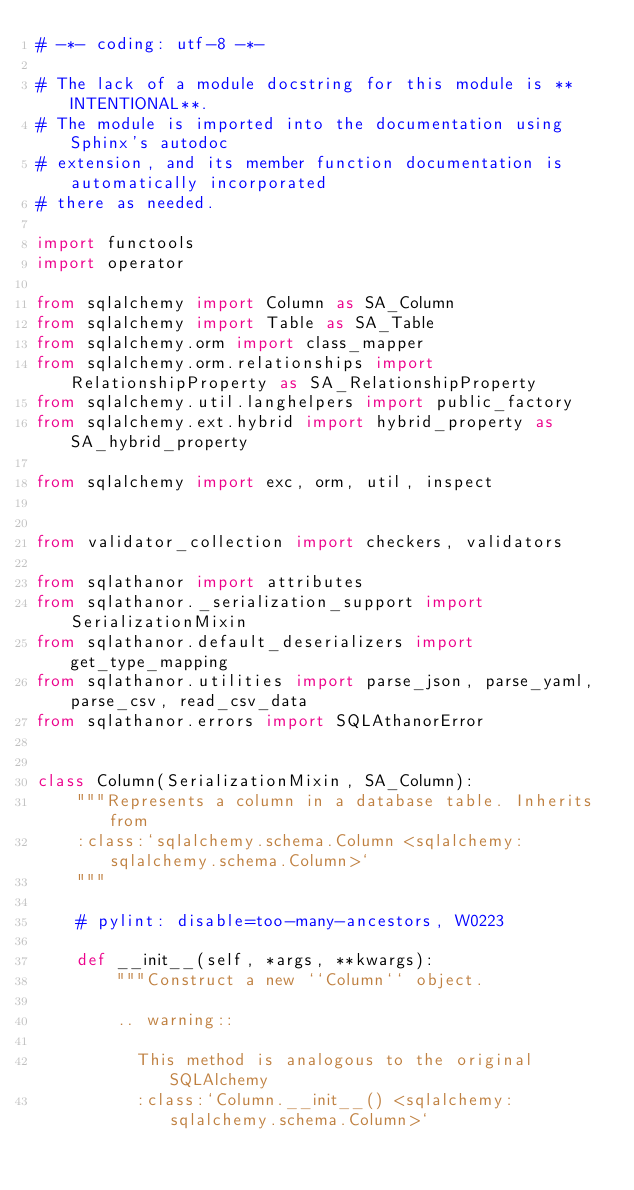<code> <loc_0><loc_0><loc_500><loc_500><_Python_># -*- coding: utf-8 -*-

# The lack of a module docstring for this module is **INTENTIONAL**.
# The module is imported into the documentation using Sphinx's autodoc
# extension, and its member function documentation is automatically incorporated
# there as needed.

import functools
import operator

from sqlalchemy import Column as SA_Column
from sqlalchemy import Table as SA_Table
from sqlalchemy.orm import class_mapper
from sqlalchemy.orm.relationships import RelationshipProperty as SA_RelationshipProperty
from sqlalchemy.util.langhelpers import public_factory
from sqlalchemy.ext.hybrid import hybrid_property as SA_hybrid_property

from sqlalchemy import exc, orm, util, inspect


from validator_collection import checkers, validators

from sqlathanor import attributes
from sqlathanor._serialization_support import SerializationMixin
from sqlathanor.default_deserializers import get_type_mapping
from sqlathanor.utilities import parse_json, parse_yaml, parse_csv, read_csv_data
from sqlathanor.errors import SQLAthanorError


class Column(SerializationMixin, SA_Column):
    """Represents a column in a database table. Inherits from
    :class:`sqlalchemy.schema.Column <sqlalchemy:sqlalchemy.schema.Column>`
    """

    # pylint: disable=too-many-ancestors, W0223

    def __init__(self, *args, **kwargs):
        """Construct a new ``Column`` object.

        .. warning::

          This method is analogous to the original SQLAlchemy
          :class:`Column.__init__() <sqlalchemy:sqlalchemy.schema.Column>`</code> 